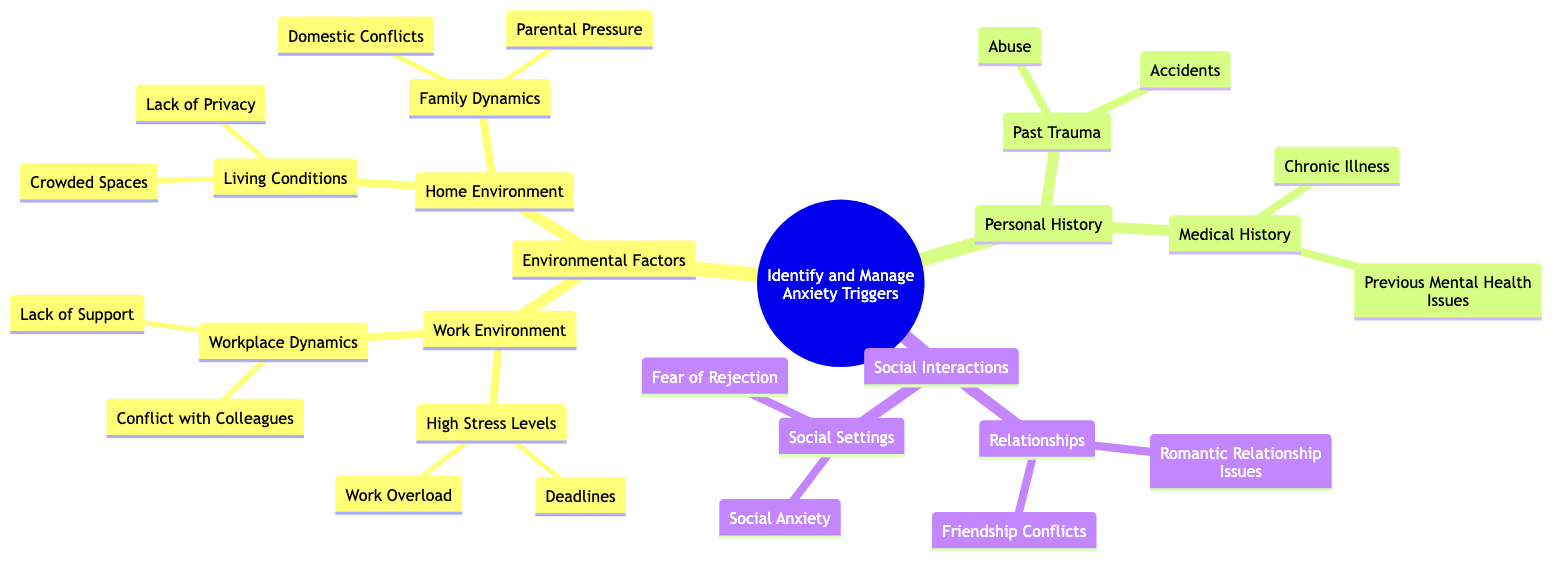What are the main categories of anxiety triggers? The diagram lists three main categories: Environmental Factors, Personal History, and Social Interactions.
Answer: Environmental Factors, Personal History, Social Interactions How many children does the "Environmental Factors" node have? The "Environmental Factors" node has two children, which are "Work Environment" and "Home Environment".
Answer: 2 What is one sub-factor under "Work Environment"? Under "Work Environment", one sub-factor is "High Stress Levels".
Answer: High Stress Levels How are "Domestic Conflicts" categorized in the diagram? "Domestic Conflicts" is categorized under "Family Dynamics", which is a child of "Home Environment" within "Environmental Factors".
Answer: Family Dynamics Which factor is associated with "Social Anxiety"? "Social Anxiety" is associated with the "Social Settings" node, which is a child of "Social Interactions".
Answer: Social Settings What are two types of personal history that could contribute to anxiety? The two types of personal history are "Past Trauma" and "Medical History".
Answer: Past Trauma, Medical History Which environmental factor might relate to a lack of personal space? The environmental factor related to a lack of personal space is "Home Environment", specifically "Living Conditions".
Answer: Living Conditions What contributes to high stress levels at work? Contributing factors to high stress levels at work are "Deadlines" and "Work Overload", which are sub-nodes under "High Stress Levels".
Answer: Deadlines, Work Overload What are two issues that can impact relationships according to the diagram? Two issues impacting relationships according to the diagram are "Romantic Relationship Issues" and "Friendship Conflicts".
Answer: Romantic Relationship Issues, Friendship Conflicts 